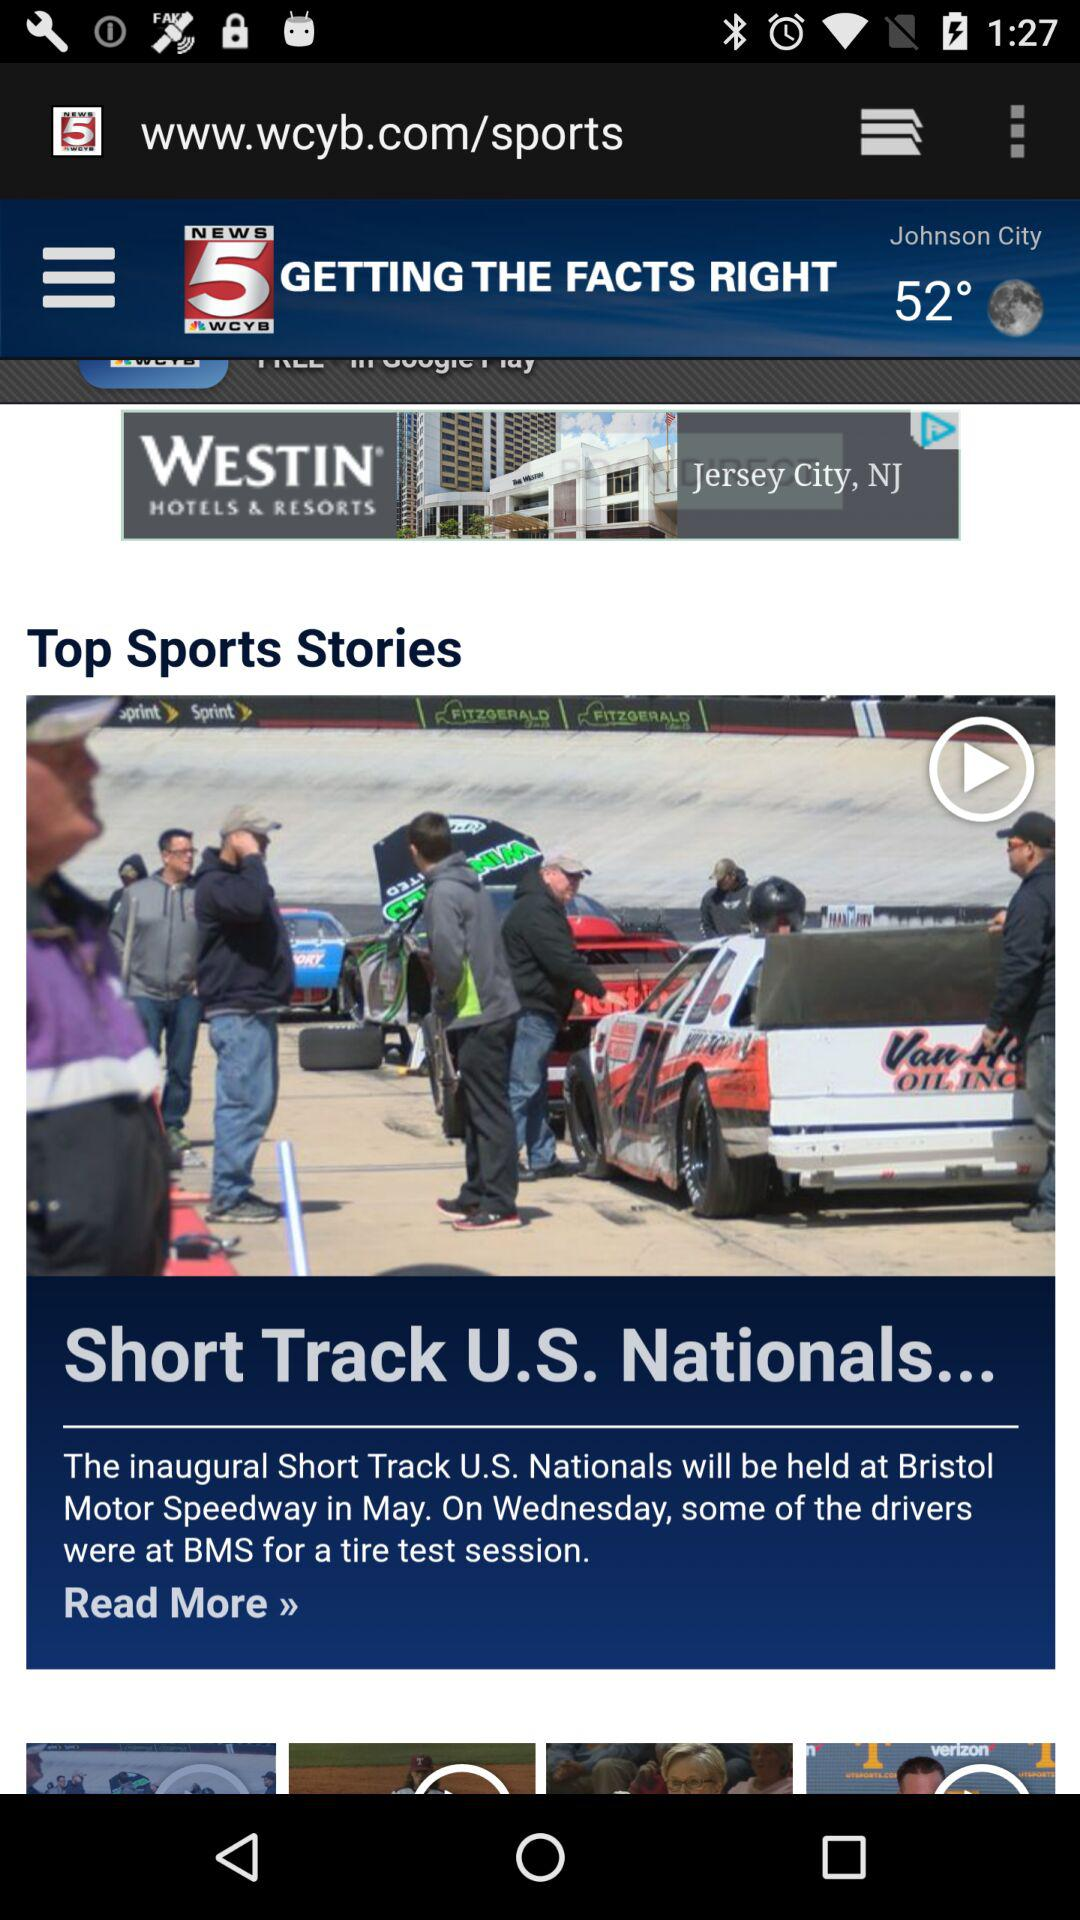What is the temperature in Johnson City? The temperature in Johnson City is 52°. 